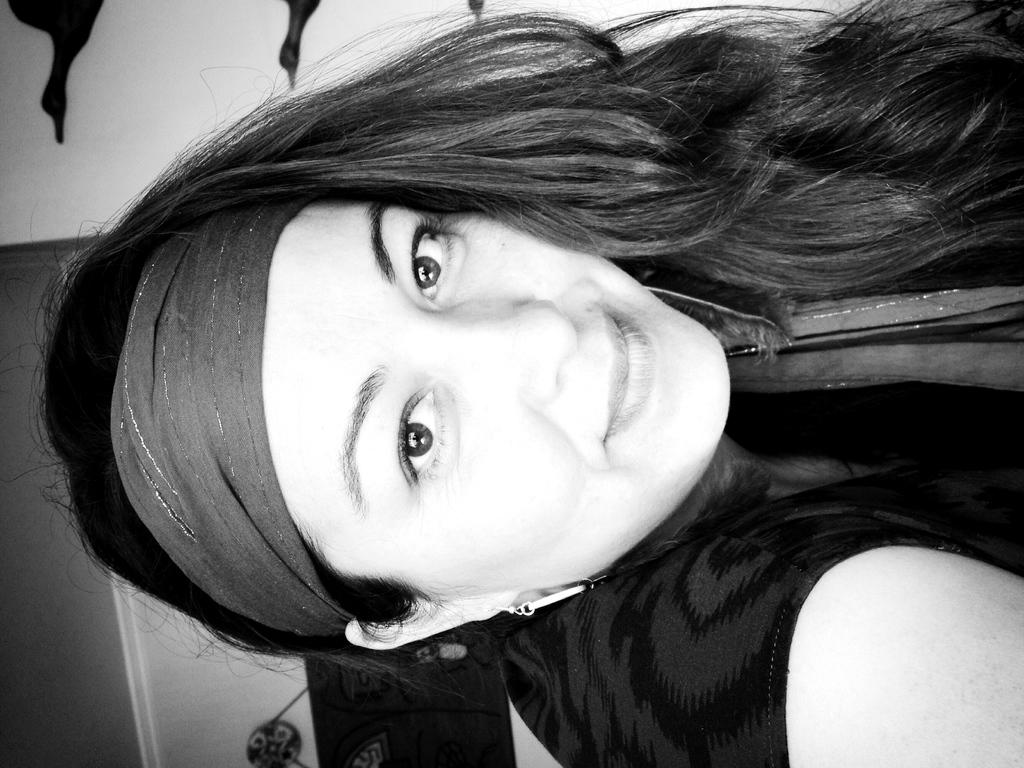What is the main subject of the image? The main subject of the image is a woman. What is the woman wearing in the image? The woman is wearing a black dress. What can be seen in the background of the image? There is a wall in the background of the image. What type of treatment is the woman receiving in the image? There is no indication in the image that the woman is receiving any treatment. What date is marked on the calendar in the image? There is no calendar present in the image. How many visitors can be seen in the image? There is no reference to any visitors in the image. 